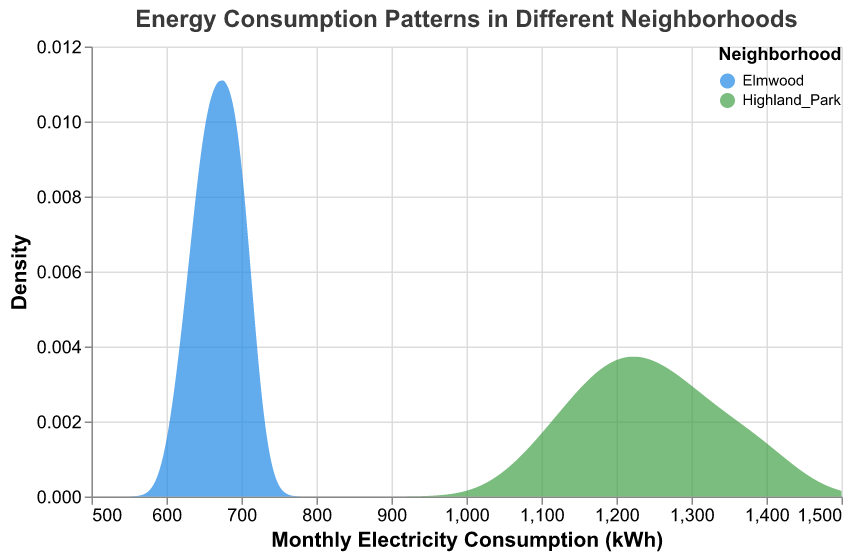What is the title of the figure? The figure's title is located at the top and reads "Energy Consumption Patterns in Different Neighborhoods."
Answer: Energy Consumption Patterns in Different Neighborhoods What are the units of Monthly Electricity Consumption on the x-axis? The units for Monthly Electricity Consumption on the x-axis are kilowatt-hours (kWh), as indicated in the x-axis title.
Answer: kWh What does the y-axis represent? The y-axis represents the "Density" of the Monthly Electricity Consumption values, as indicated by the y-axis title.
Answer: Density Which two neighborhoods are compared in the figure? The neighborhoods compared are named in the color legend and are "Highland Park" and "Elmwood."
Answer: Highland Park and Elmwood Which neighborhood shows a higher density for lower values of Monthly Electricity Consumption? By looking at the density areas, Elmwood shows a higher density for lower values of Monthly Electricity Consumption.
Answer: Elmwood What is the approximate range of Monthly Electricity Consumption values for Highland Park? The density plot for Highland Park extends approximately from 1100 kWh to 1400 kWh.
Answer: 1100 kWh to 1400 kWh Are the density curves overlapping, and if so, where? The density curves overlap mostly around the 1100 kWh to 1300 kWh range, within which both neighborhoods have values.
Answer: Yes, around 1100 kWh to 1300 kWh What does a higher peak in the density plot signify? A higher peak in the density plot signifies a greater concentration of households with that specific Monthly Electricity Consumption value.
Answer: Greater concentration Which neighborhood exhibits a wider range of Monthly Electricity Consumption? Highland Park exhibits a wider range of Monthly Electricity Consumption values, as seen by its wider spread on the x-axis.
Answer: Highland Park 